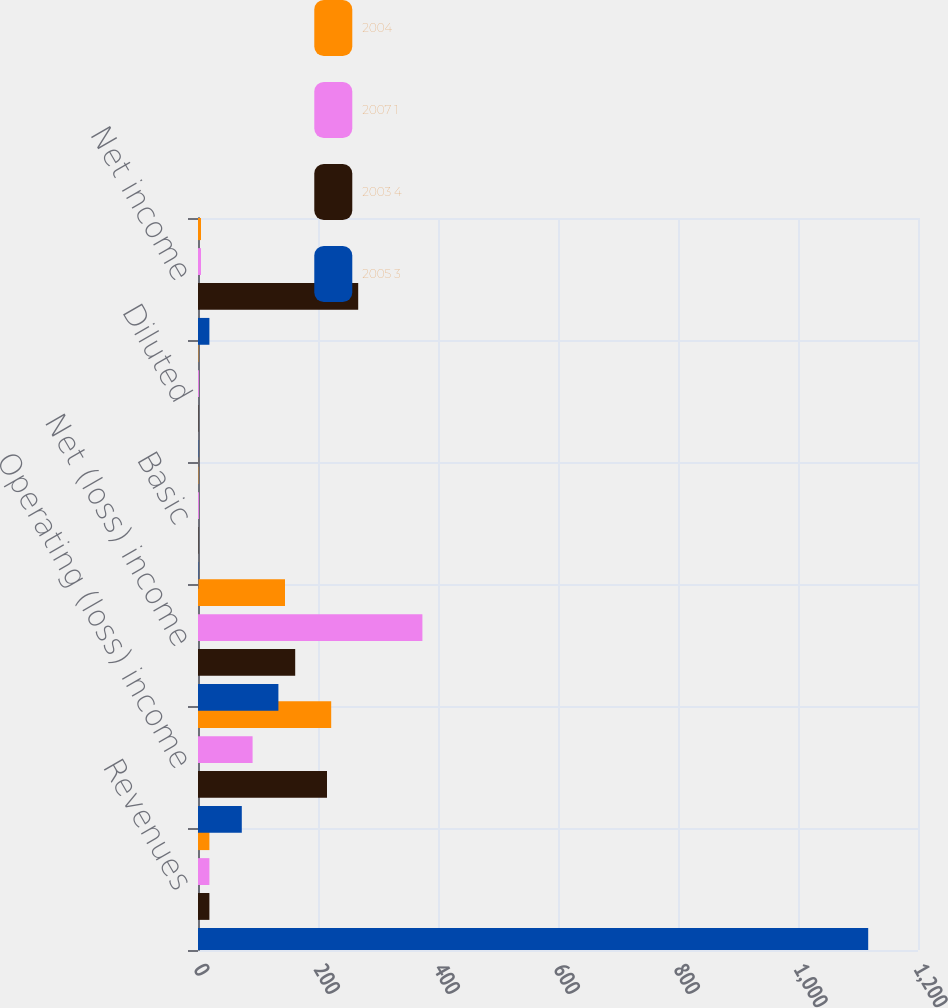<chart> <loc_0><loc_0><loc_500><loc_500><stacked_bar_chart><ecel><fcel>Revenues<fcel>Operating (loss) income<fcel>Net (loss) income<fcel>Basic<fcel>Diluted<fcel>Net income<nl><fcel>2004<fcel>19<fcel>222<fcel>145<fcel>0.61<fcel>0.61<fcel>5<nl><fcel>2007 1<fcel>19<fcel>91<fcel>374<fcel>1.53<fcel>1.51<fcel>5<nl><fcel>2003 4<fcel>19<fcel>215<fcel>162<fcel>0.63<fcel>0.62<fcel>267<nl><fcel>2005 3<fcel>1117<fcel>73<fcel>134<fcel>0.53<fcel>0.52<fcel>19<nl></chart> 